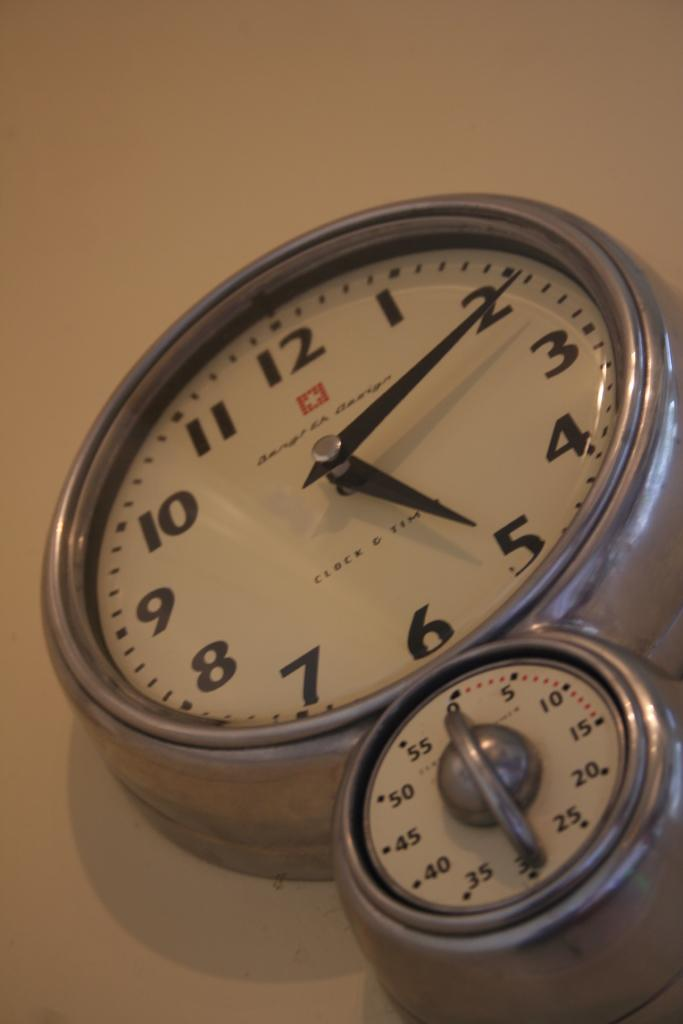<image>
Relay a brief, clear account of the picture shown. Clock and Time that says 5:10 and has a small timer on the bottom. 